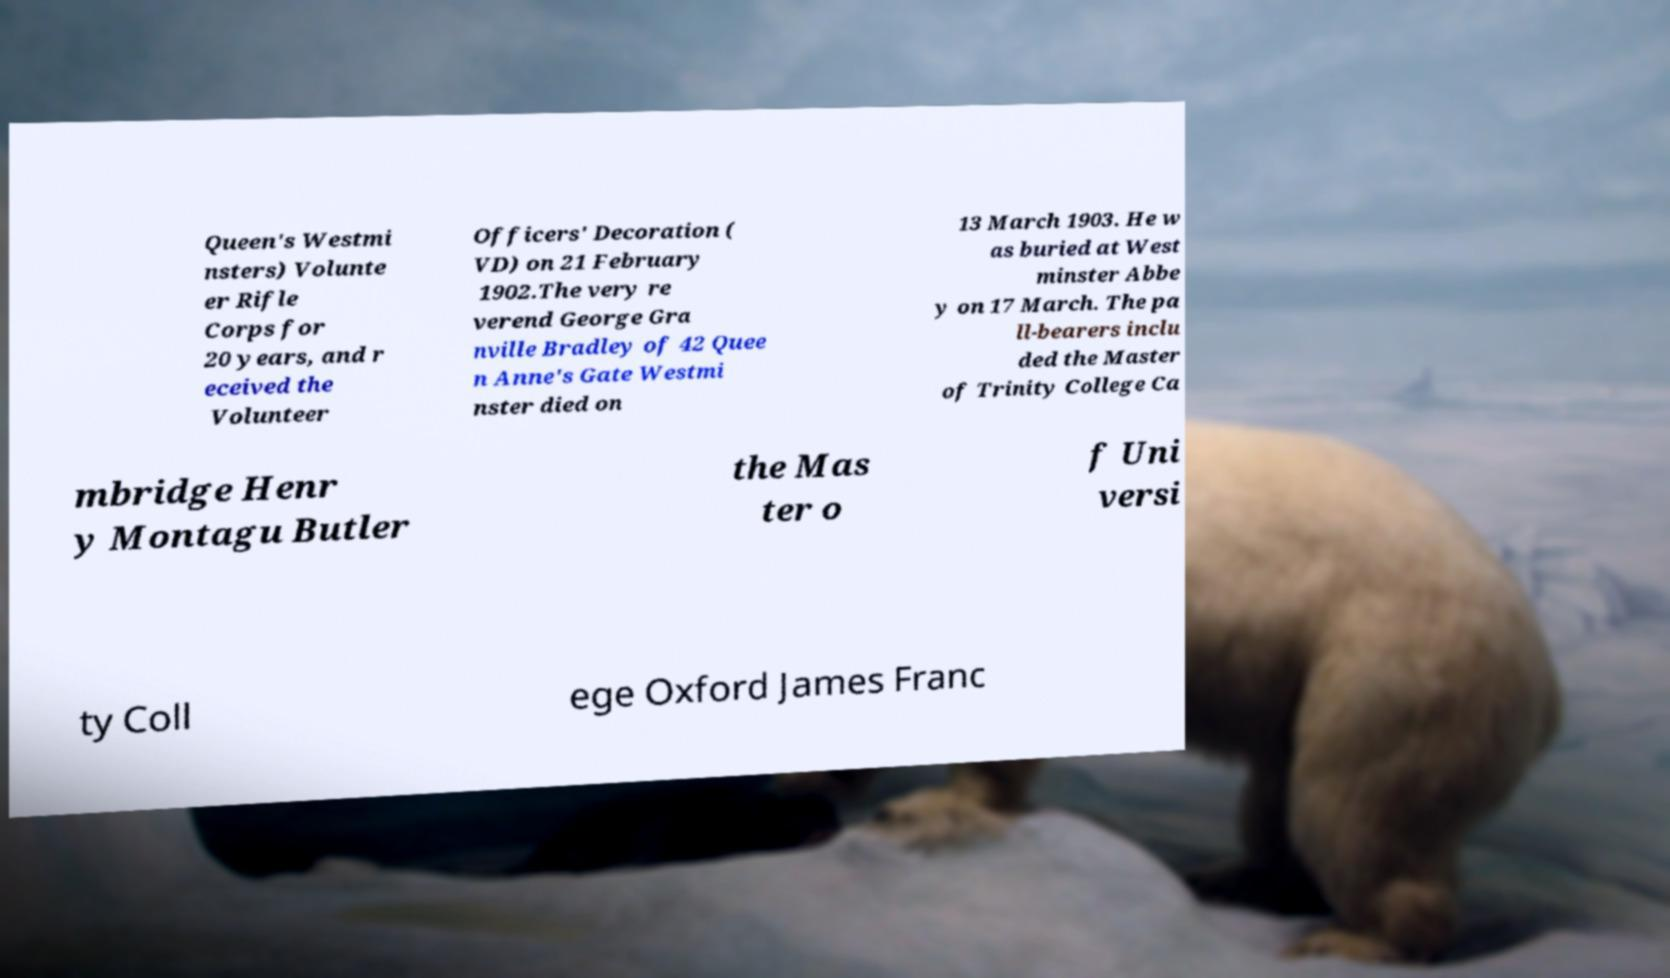Could you assist in decoding the text presented in this image and type it out clearly? Queen's Westmi nsters) Volunte er Rifle Corps for 20 years, and r eceived the Volunteer Officers' Decoration ( VD) on 21 February 1902.The very re verend George Gra nville Bradley of 42 Quee n Anne's Gate Westmi nster died on 13 March 1903. He w as buried at West minster Abbe y on 17 March. The pa ll-bearers inclu ded the Master of Trinity College Ca mbridge Henr y Montagu Butler the Mas ter o f Uni versi ty Coll ege Oxford James Franc 